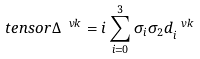<formula> <loc_0><loc_0><loc_500><loc_500>\ t e n s o r { \Delta } ^ { \ v k } = i \sum _ { i = 0 } ^ { 3 } \sigma _ { i } \sigma _ { 2 } d _ { i } ^ { \ v k }</formula> 